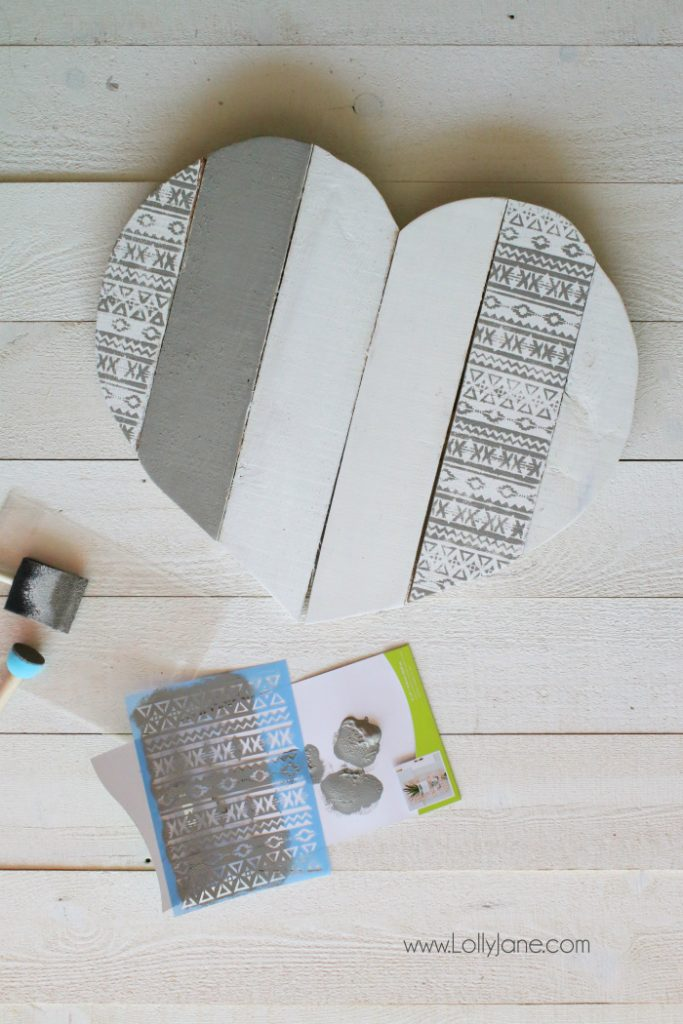Considering the pattern visible on the wooden heart and the stencil lying next to it, what might be the sequence of steps that the creator followed to achieve the patterned design on the wooden heart? To achieve the beautiful patterned design on the wooden heart, the creator likely followed these steps: First, they carefully assembled the wooden heart using individual planks and painted the whole surface with a base coat of white and gray paint. After allowing the base coat to dry, they positioned the stencil over one of the white planks, ensuring it was placed precisely where the pattern was desired. Utilizing a foam paint roller, they applied a contrasting paint color, probably a darker shade such as gray or black, over the stencil. This process would transfer the intricate geometric pattern onto the wooden surface. The stencil was then removed to reveal the design and placed to the side, likely for drying or cleaning, as evidenced by the paint marks on the paper beneath the stencil. Finally, the process was repeated for each section where the pattern was needed, resulting in the stunning, patterned wooden heart seen in the image. 